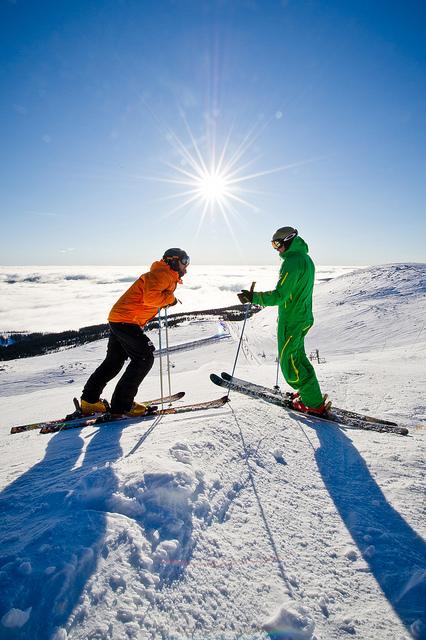What are they standing on?
Give a very brief answer. Snow. What season is this?
Write a very short answer. Winter. Are they talking to each other?
Keep it brief. Yes. 